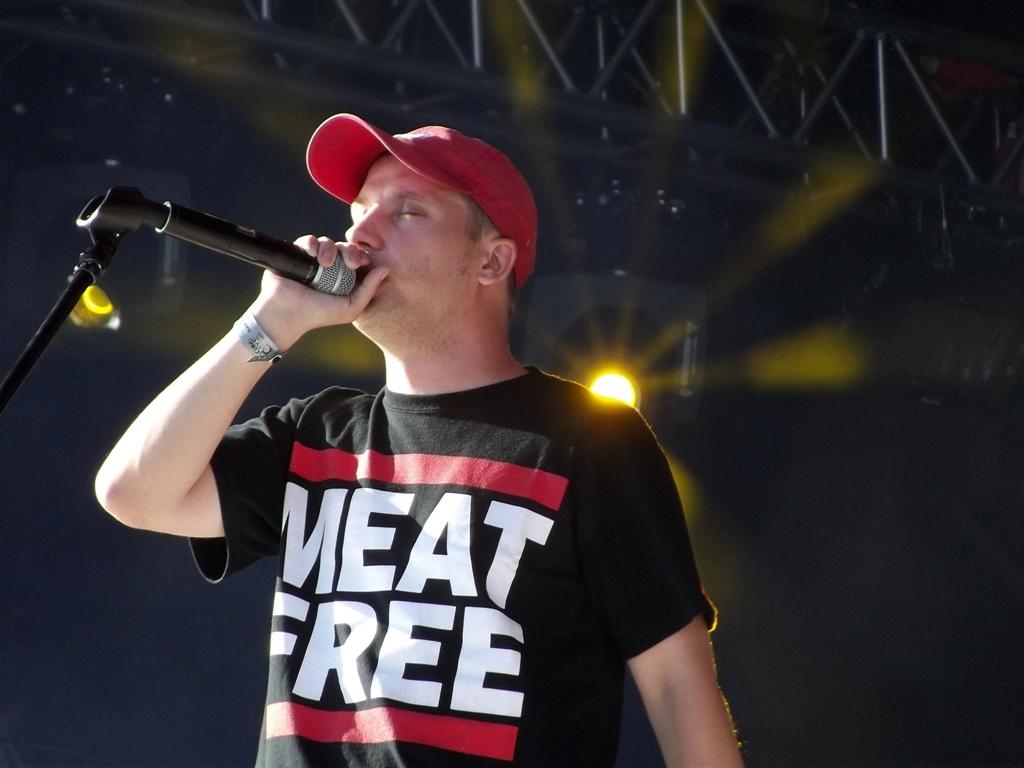Who is present in the image? There is a man in the image. What is the man wearing on his upper body? The man is wearing a black t-shirt. What object is the man holding in his hand? The man is holding a microphone in his hand. What type of headwear is the man wearing? The man is wearing a red cap on his head. What can be seen in the background of the image? There is a light in the background of the image. What type of rifle is the man holding in the image? There is no rifle present in the image; the man is holding a microphone. What substance is the man using to enhance his performance in the image? There is no indication of any substance being used in the image; the man is simply holding a microphone. 